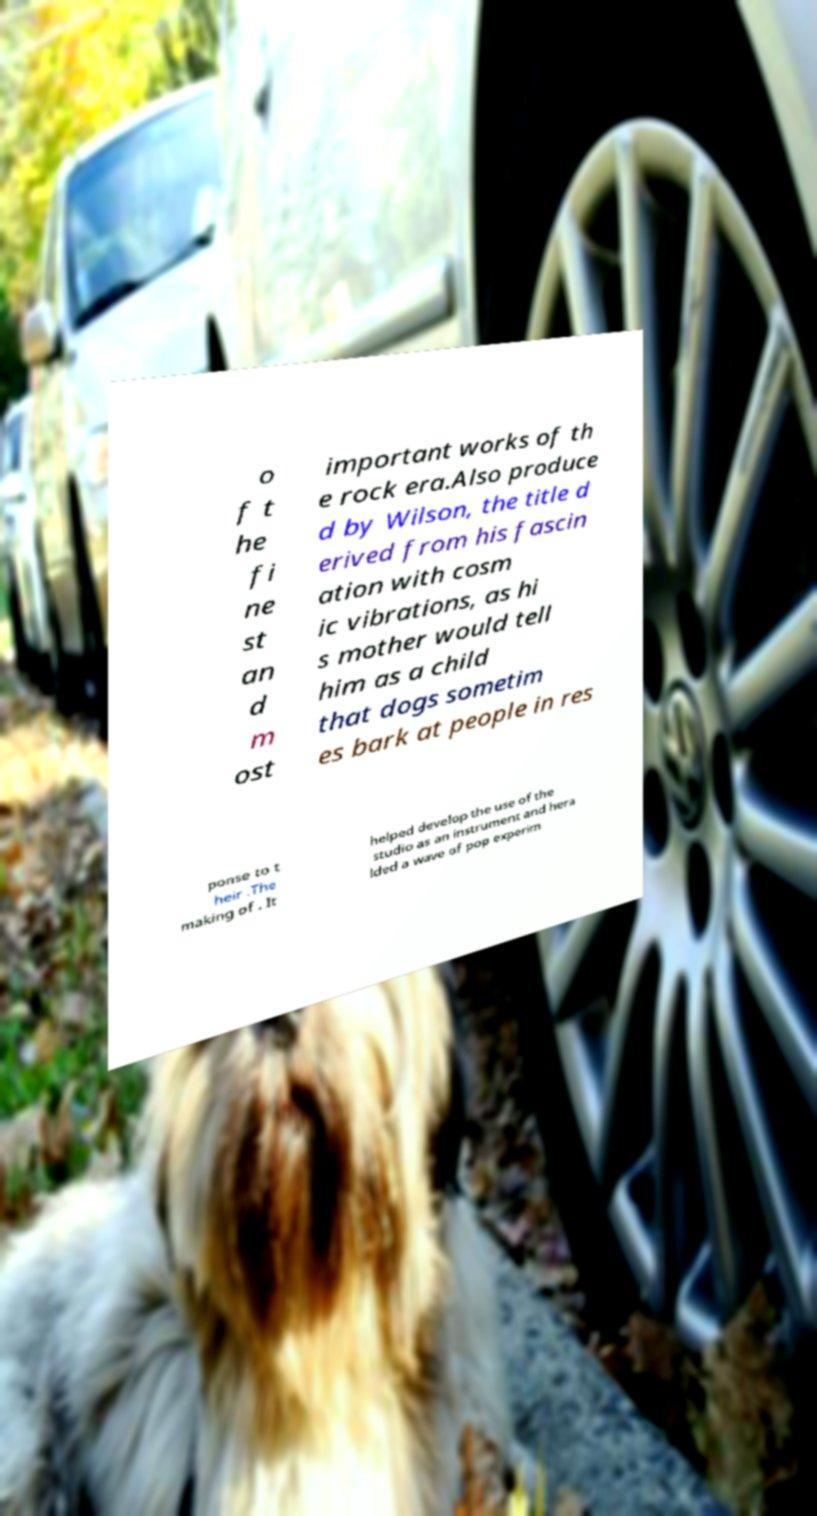Please identify and transcribe the text found in this image. o f t he fi ne st an d m ost important works of th e rock era.Also produce d by Wilson, the title d erived from his fascin ation with cosm ic vibrations, as hi s mother would tell him as a child that dogs sometim es bark at people in res ponse to t heir .The making of . It helped develop the use of the studio as an instrument and hera lded a wave of pop experim 